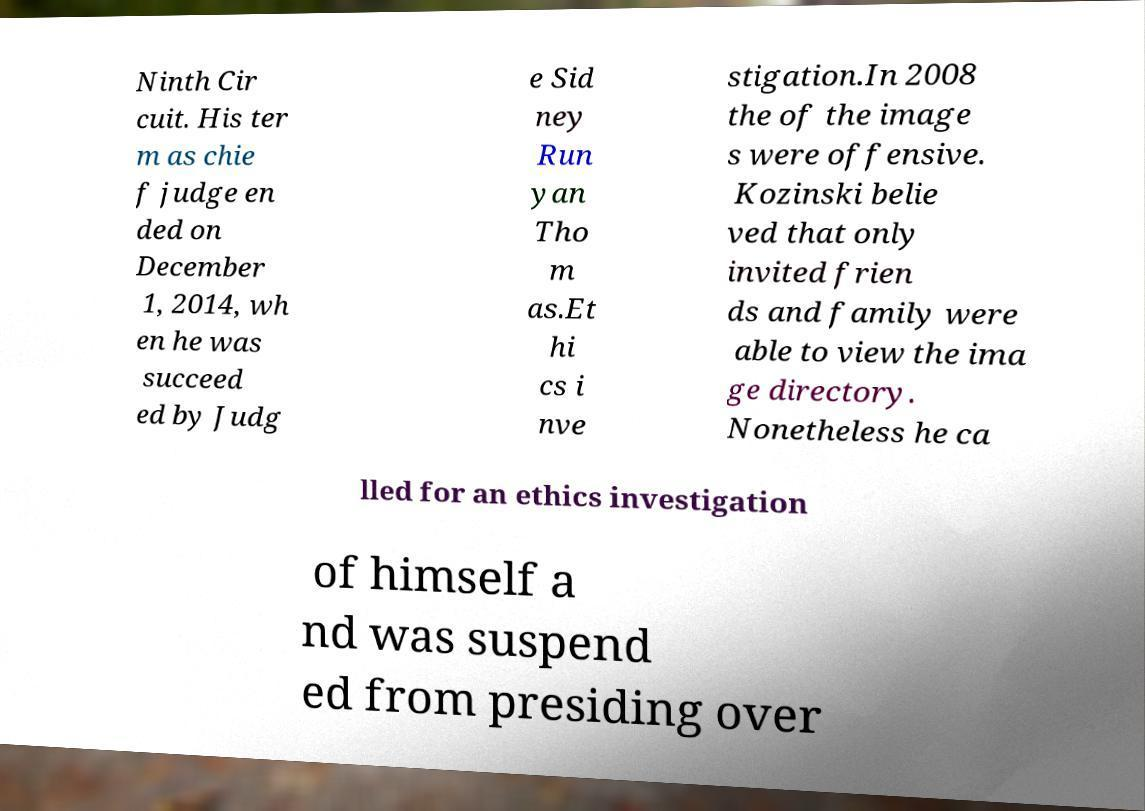Could you assist in decoding the text presented in this image and type it out clearly? Ninth Cir cuit. His ter m as chie f judge en ded on December 1, 2014, wh en he was succeed ed by Judg e Sid ney Run yan Tho m as.Et hi cs i nve stigation.In 2008 the of the image s were offensive. Kozinski belie ved that only invited frien ds and family were able to view the ima ge directory. Nonetheless he ca lled for an ethics investigation of himself a nd was suspend ed from presiding over 